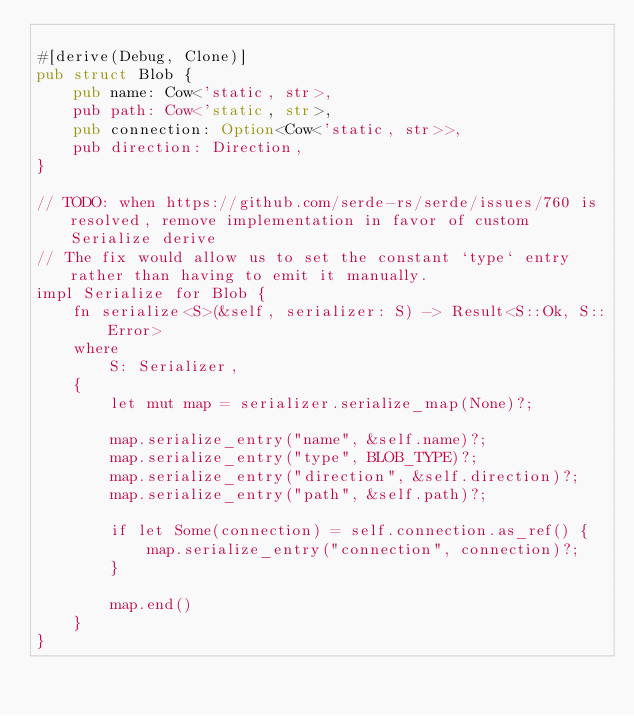Convert code to text. <code><loc_0><loc_0><loc_500><loc_500><_Rust_>
#[derive(Debug, Clone)]
pub struct Blob {
    pub name: Cow<'static, str>,
    pub path: Cow<'static, str>,
    pub connection: Option<Cow<'static, str>>,
    pub direction: Direction,
}

// TODO: when https://github.com/serde-rs/serde/issues/760 is resolved, remove implementation in favor of custom Serialize derive
// The fix would allow us to set the constant `type` entry rather than having to emit it manually.
impl Serialize for Blob {
    fn serialize<S>(&self, serializer: S) -> Result<S::Ok, S::Error>
    where
        S: Serializer,
    {
        let mut map = serializer.serialize_map(None)?;

        map.serialize_entry("name", &self.name)?;
        map.serialize_entry("type", BLOB_TYPE)?;
        map.serialize_entry("direction", &self.direction)?;
        map.serialize_entry("path", &self.path)?;

        if let Some(connection) = self.connection.as_ref() {
            map.serialize_entry("connection", connection)?;
        }

        map.end()
    }
}
</code> 